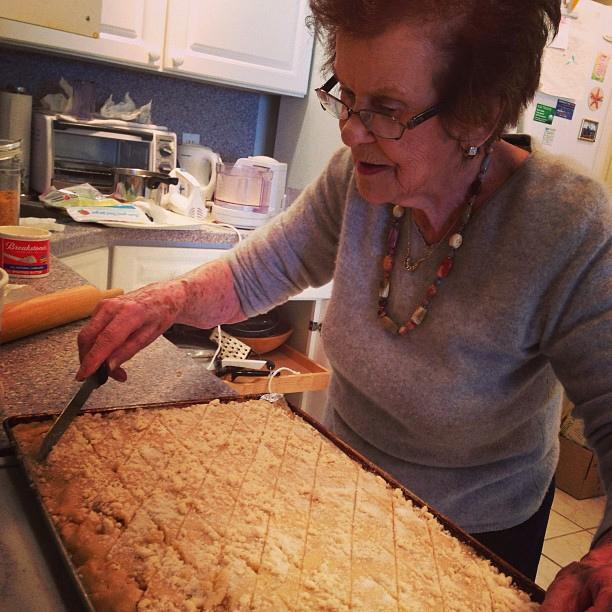What is the woman doing to her cake? cutting 